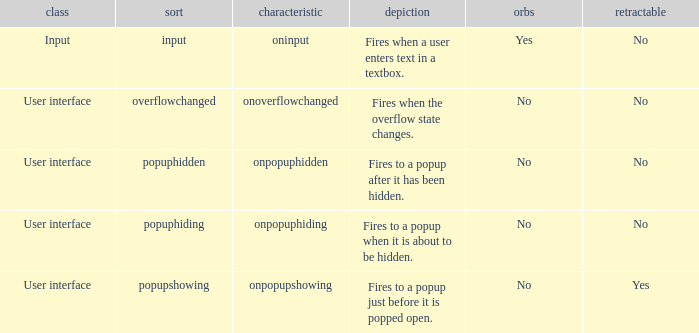What's the attribute with cancelable being yes Onpopupshowing. Parse the full table. {'header': ['class', 'sort', 'characteristic', 'depiction', 'orbs', 'retractable'], 'rows': [['Input', 'input', 'oninput', 'Fires when a user enters text in a textbox.', 'Yes', 'No'], ['User interface', 'overflowchanged', 'onoverflowchanged', 'Fires when the overflow state changes.', 'No', 'No'], ['User interface', 'popuphidden', 'onpopuphidden', 'Fires to a popup after it has been hidden.', 'No', 'No'], ['User interface', 'popuphiding', 'onpopuphiding', 'Fires to a popup when it is about to be hidden.', 'No', 'No'], ['User interface', 'popupshowing', 'onpopupshowing', 'Fires to a popup just before it is popped open.', 'No', 'Yes']]} 